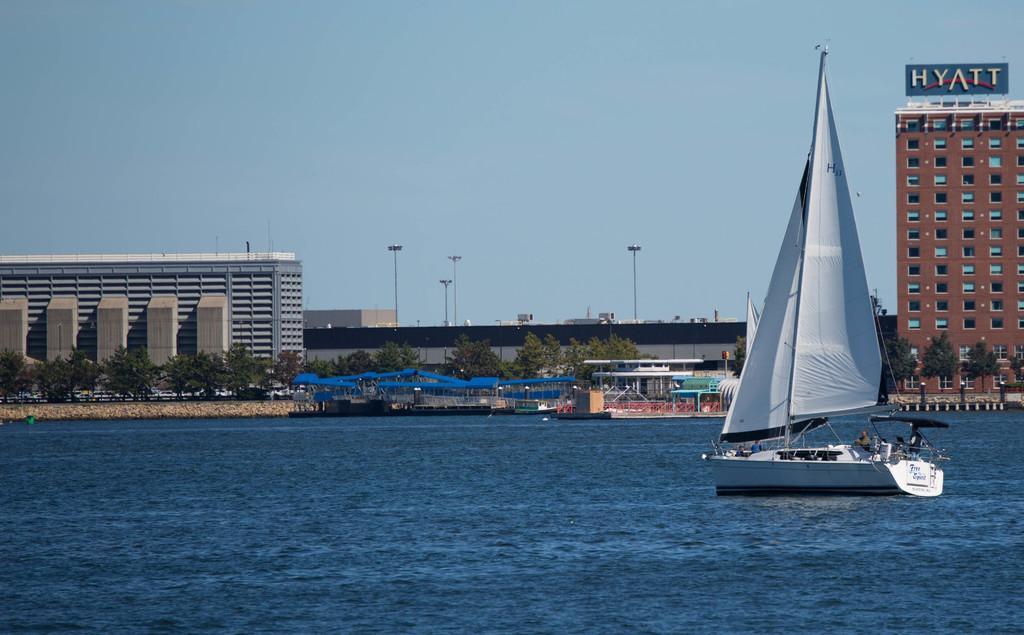Can you describe this image briefly? In the picture we can see the water, which is blue in color and in it we can see a boat which is white in color and behind it, we can see some boats are parked and behind it, we can see some trees and building and we can see a tower building with windows and a name on top of it as HYATT and in the background we can see some poles and sky. 